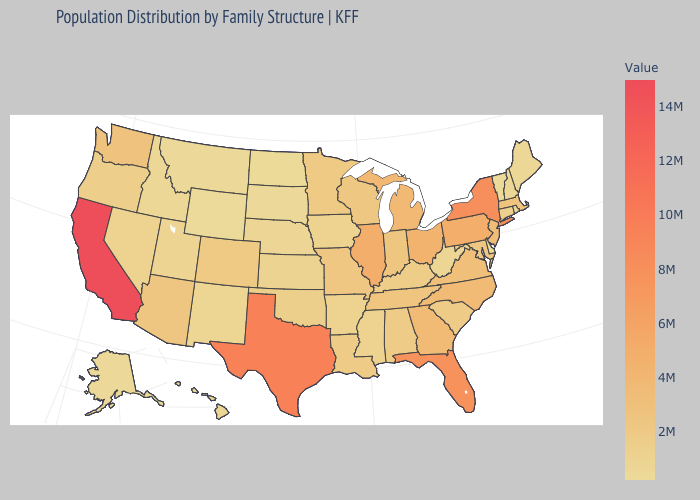Which states have the lowest value in the West?
Be succinct. Wyoming. Does California have a higher value than Arkansas?
Answer briefly. Yes. Which states have the lowest value in the USA?
Be succinct. Wyoming. Among the states that border Illinois , which have the highest value?
Short answer required. Indiana. Does Nevada have the lowest value in the West?
Give a very brief answer. No. Among the states that border Kansas , which have the lowest value?
Answer briefly. Nebraska. Does California have the highest value in the USA?
Answer briefly. Yes. 